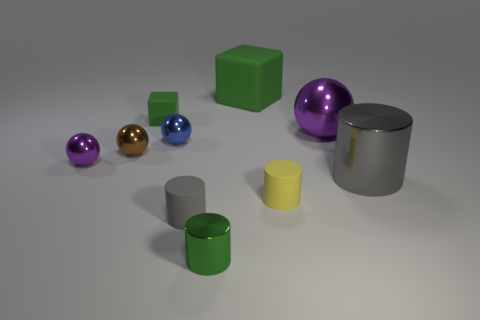Is the size of the green matte thing that is right of the tiny gray cylinder the same as the purple ball to the right of the tiny yellow cylinder?
Provide a short and direct response. Yes. There is a large object that is the same shape as the small brown shiny thing; what is its color?
Give a very brief answer. Purple. Is there any other thing that is the same shape as the tiny green rubber object?
Give a very brief answer. Yes. Are there more green objects that are behind the big green rubber block than small metal things to the right of the small purple ball?
Your answer should be compact. No. How big is the purple ball right of the purple thing on the left side of the purple sphere behind the blue metal ball?
Offer a very short reply. Large. Is the material of the big gray object the same as the small green object left of the tiny green metal cylinder?
Your response must be concise. No. Do the big rubber thing and the small green matte thing have the same shape?
Your answer should be compact. Yes. How many other things are there of the same material as the tiny brown object?
Give a very brief answer. 5. What number of tiny brown shiny things have the same shape as the large gray object?
Your answer should be compact. 0. There is a object that is behind the tiny blue object and to the left of the gray matte thing; what color is it?
Ensure brevity in your answer.  Green. 